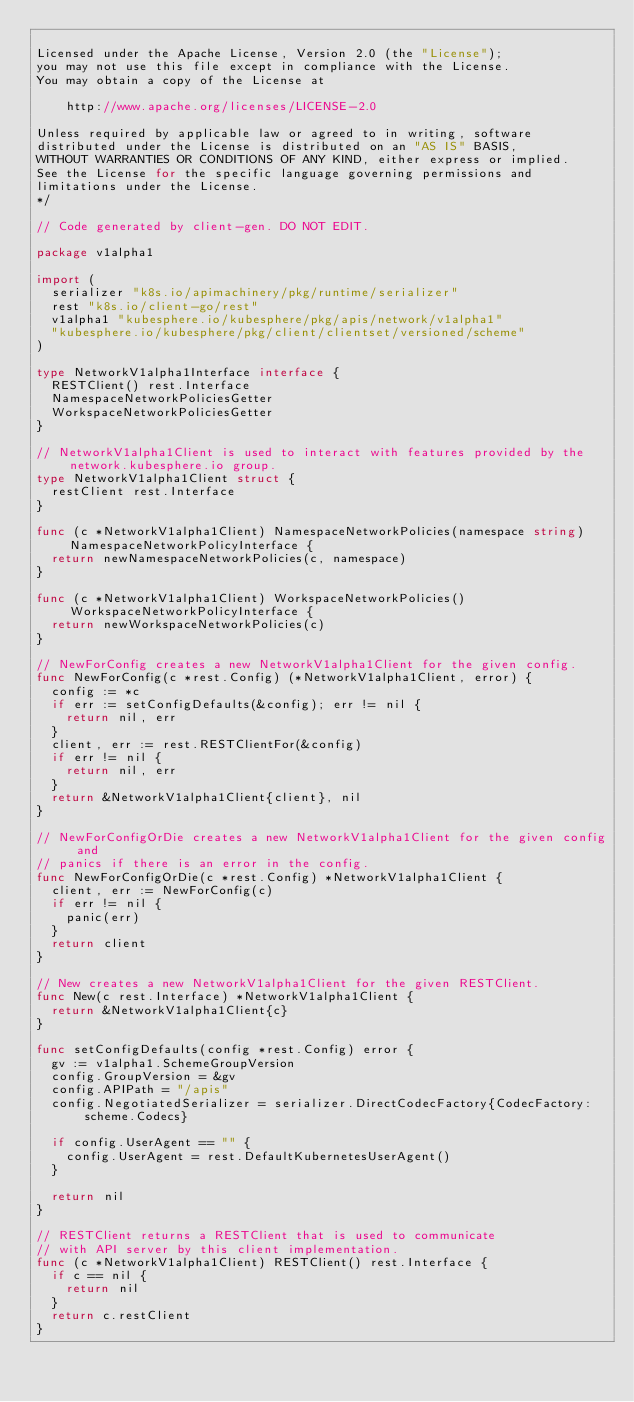Convert code to text. <code><loc_0><loc_0><loc_500><loc_500><_Go_>
Licensed under the Apache License, Version 2.0 (the "License");
you may not use this file except in compliance with the License.
You may obtain a copy of the License at

    http://www.apache.org/licenses/LICENSE-2.0

Unless required by applicable law or agreed to in writing, software
distributed under the License is distributed on an "AS IS" BASIS,
WITHOUT WARRANTIES OR CONDITIONS OF ANY KIND, either express or implied.
See the License for the specific language governing permissions and
limitations under the License.
*/

// Code generated by client-gen. DO NOT EDIT.

package v1alpha1

import (
	serializer "k8s.io/apimachinery/pkg/runtime/serializer"
	rest "k8s.io/client-go/rest"
	v1alpha1 "kubesphere.io/kubesphere/pkg/apis/network/v1alpha1"
	"kubesphere.io/kubesphere/pkg/client/clientset/versioned/scheme"
)

type NetworkV1alpha1Interface interface {
	RESTClient() rest.Interface
	NamespaceNetworkPoliciesGetter
	WorkspaceNetworkPoliciesGetter
}

// NetworkV1alpha1Client is used to interact with features provided by the network.kubesphere.io group.
type NetworkV1alpha1Client struct {
	restClient rest.Interface
}

func (c *NetworkV1alpha1Client) NamespaceNetworkPolicies(namespace string) NamespaceNetworkPolicyInterface {
	return newNamespaceNetworkPolicies(c, namespace)
}

func (c *NetworkV1alpha1Client) WorkspaceNetworkPolicies() WorkspaceNetworkPolicyInterface {
	return newWorkspaceNetworkPolicies(c)
}

// NewForConfig creates a new NetworkV1alpha1Client for the given config.
func NewForConfig(c *rest.Config) (*NetworkV1alpha1Client, error) {
	config := *c
	if err := setConfigDefaults(&config); err != nil {
		return nil, err
	}
	client, err := rest.RESTClientFor(&config)
	if err != nil {
		return nil, err
	}
	return &NetworkV1alpha1Client{client}, nil
}

// NewForConfigOrDie creates a new NetworkV1alpha1Client for the given config and
// panics if there is an error in the config.
func NewForConfigOrDie(c *rest.Config) *NetworkV1alpha1Client {
	client, err := NewForConfig(c)
	if err != nil {
		panic(err)
	}
	return client
}

// New creates a new NetworkV1alpha1Client for the given RESTClient.
func New(c rest.Interface) *NetworkV1alpha1Client {
	return &NetworkV1alpha1Client{c}
}

func setConfigDefaults(config *rest.Config) error {
	gv := v1alpha1.SchemeGroupVersion
	config.GroupVersion = &gv
	config.APIPath = "/apis"
	config.NegotiatedSerializer = serializer.DirectCodecFactory{CodecFactory: scheme.Codecs}

	if config.UserAgent == "" {
		config.UserAgent = rest.DefaultKubernetesUserAgent()
	}

	return nil
}

// RESTClient returns a RESTClient that is used to communicate
// with API server by this client implementation.
func (c *NetworkV1alpha1Client) RESTClient() rest.Interface {
	if c == nil {
		return nil
	}
	return c.restClient
}
</code> 